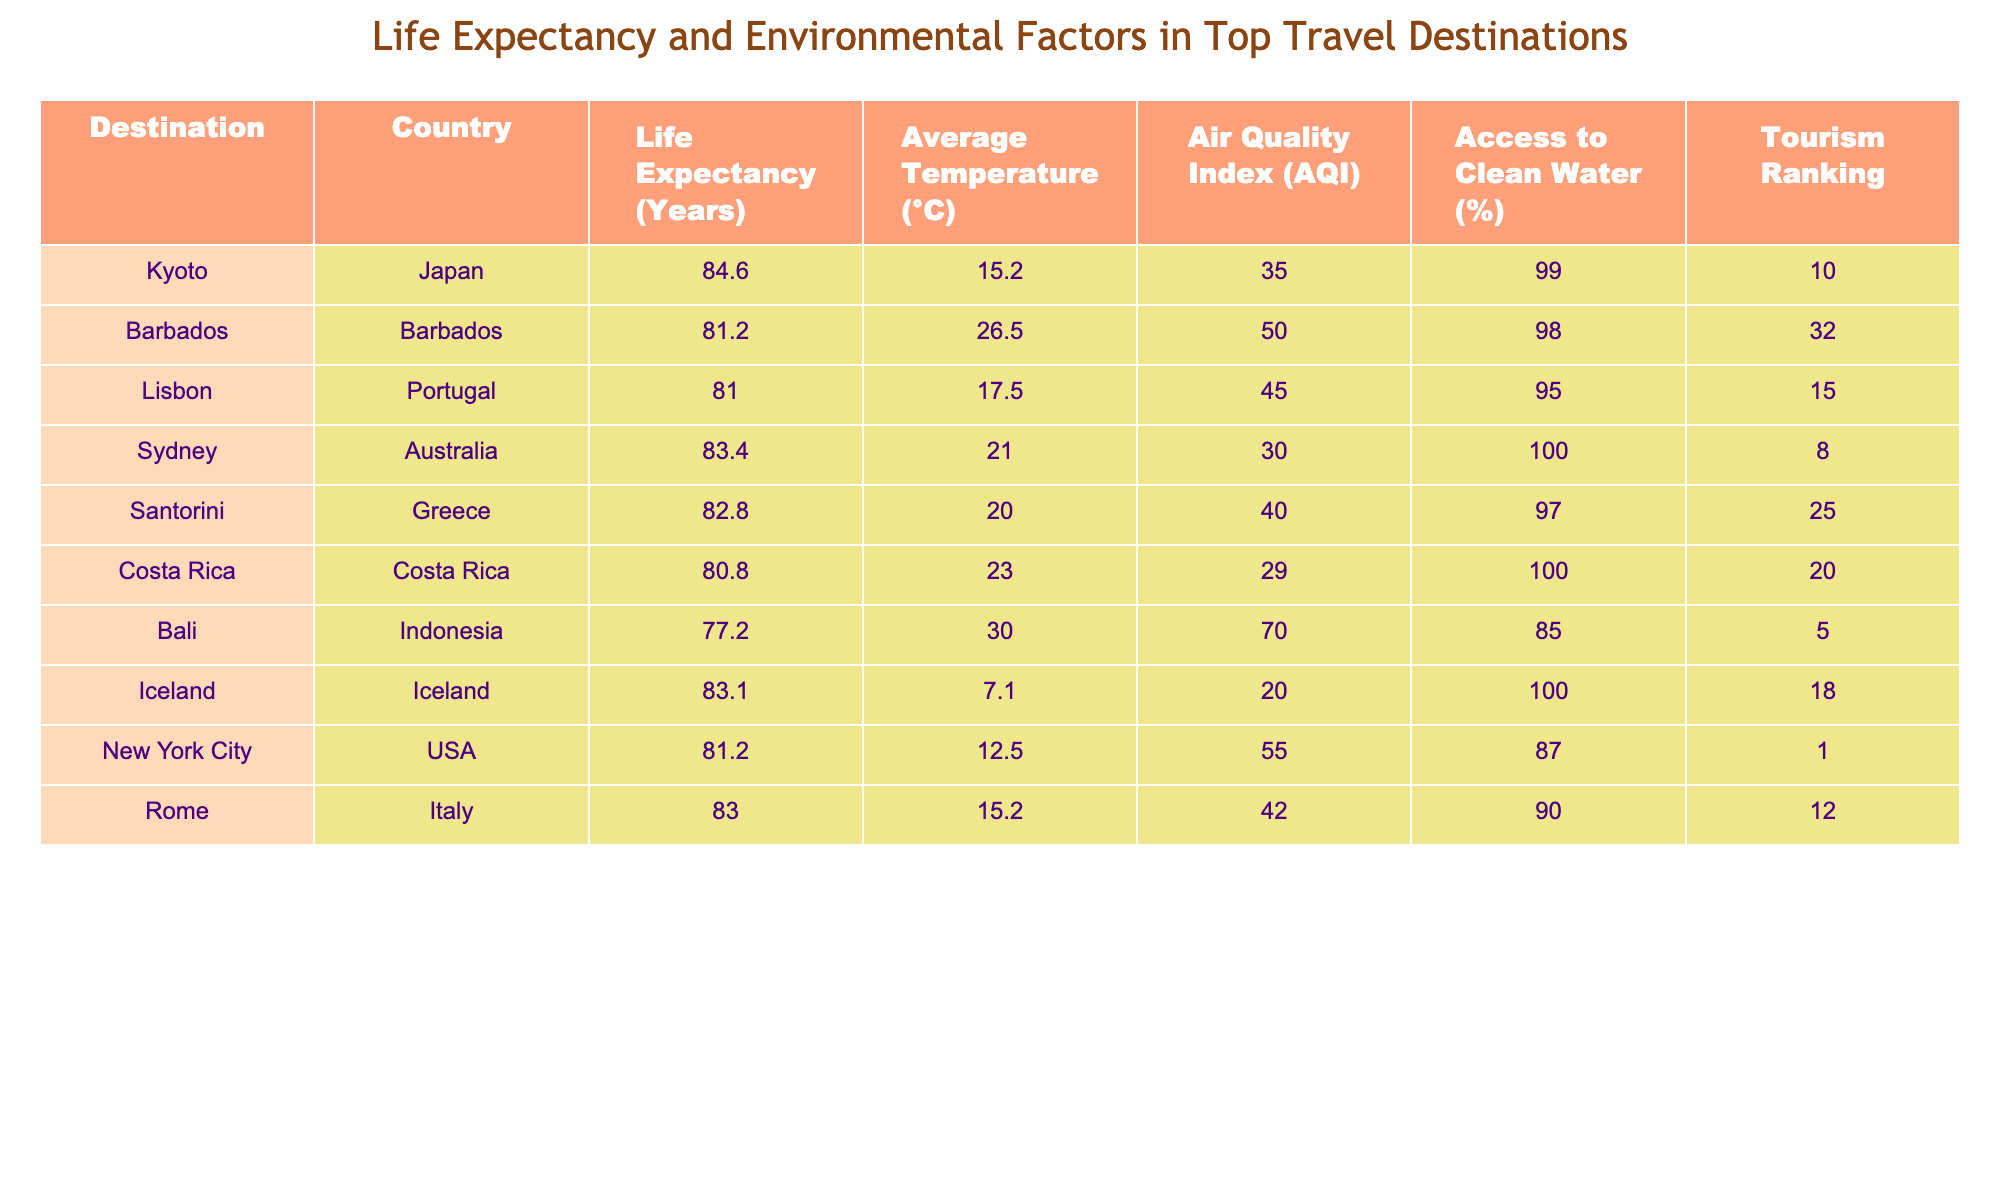What is the life expectancy in Kyoto? The table provides a specific entry for Kyoto, where the life expectancy is clearly stated as 84.6 years.
Answer: 84.6 Which destination has the highest air quality index? By comparing the AQI values listed for each destination, I find that Iceland has the highest AQI at 20.
Answer: Iceland What is the average life expectancy of all the destinations listed? To find the average life expectancy, I will sum all the life expectancies: 84.6 + 81.2 + 81.0 + 83.4 + 82.8 + 80.8 + 77.2 + 83.1 + 81.2 + 83.0 = 828.3. There are 10 destinations, so the average is 828.3 / 10 = 82.83 years.
Answer: 82.83 Is the average temperature in the destinations generally above 20 degrees Celsius? I will check the average temperatures of all destinations: 15.2, 26.5, 17.5, 21.0, 20.0, 23.0, 30.0, 7.1, 12.5, and 15.2. The sum is 15.2 + 26.5 + 17.5 + 21.0 + 20.0 + 23.0 + 30.0 + 7.1 + 12.5 + 15.2 =  284.0. The average is 284.0 / 10 = 28.4. Since 28.4 > 20, the statement is true.
Answer: Yes Is there a correlation between high life expectancy and access to clean water based on the table? To analyze this, we compare the life expectancy and access to clean water for the highest and lowest percentages. The highest life expectancy is in Kyoto (84.6) with 99% access, and the lowest is Bali (77.2) with 85% access. This suggests a potential correlation, as higher life expectancy corresponds with higher clean water access. However, more data points would be needed for a definitive conclusion.
Answer: Yes 